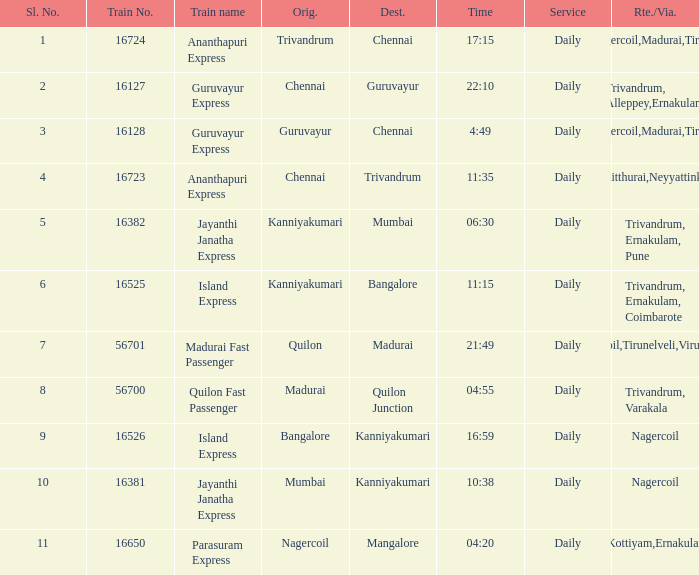What is the origin when the destination is Mumbai? Kanniyakumari. 